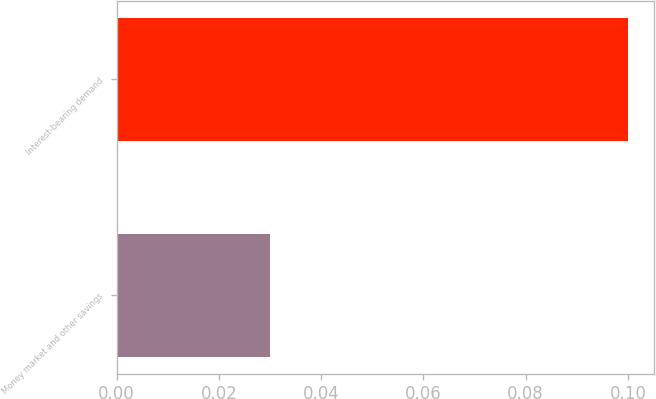Convert chart to OTSL. <chart><loc_0><loc_0><loc_500><loc_500><bar_chart><fcel>Money market and other savings<fcel>Interest-bearing demand<nl><fcel>0.03<fcel>0.1<nl></chart> 